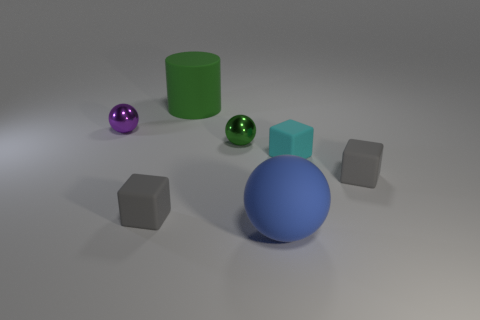Subtract all small purple balls. How many balls are left? 2 Subtract all purple spheres. How many spheres are left? 2 Subtract all brown spheres. How many yellow cubes are left? 0 Subtract all big green things. Subtract all tiny metal spheres. How many objects are left? 4 Add 6 big spheres. How many big spheres are left? 7 Add 1 spheres. How many spheres exist? 4 Add 2 small purple shiny spheres. How many objects exist? 9 Subtract 1 purple balls. How many objects are left? 6 Subtract all spheres. How many objects are left? 4 Subtract 1 cylinders. How many cylinders are left? 0 